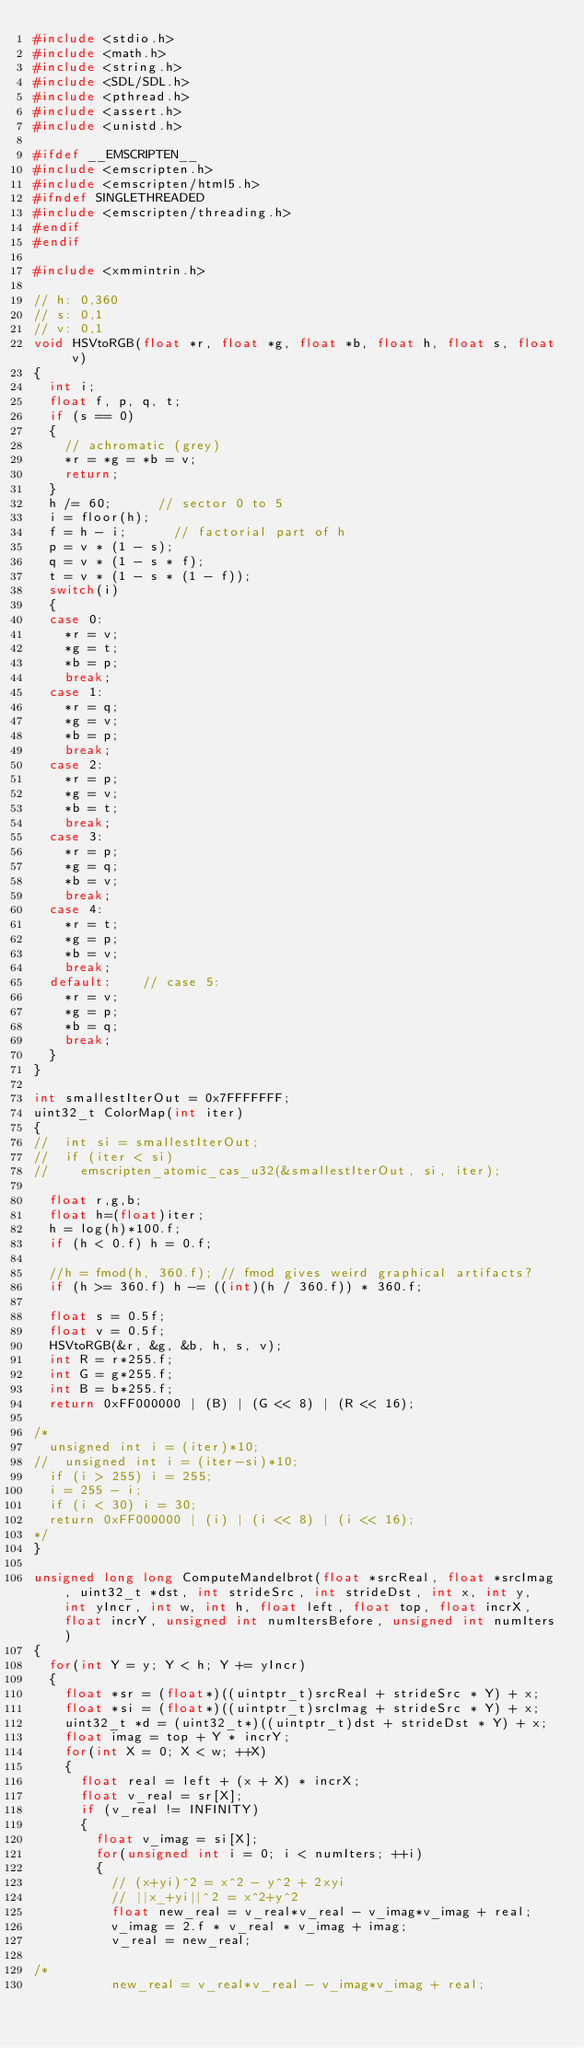<code> <loc_0><loc_0><loc_500><loc_500><_C++_>#include <stdio.h>
#include <math.h>
#include <string.h>
#include <SDL/SDL.h>
#include <pthread.h>
#include <assert.h>
#include <unistd.h>

#ifdef __EMSCRIPTEN__
#include <emscripten.h>
#include <emscripten/html5.h>
#ifndef SINGLETHREADED
#include <emscripten/threading.h>
#endif
#endif

#include <xmmintrin.h>

// h: 0,360
// s: 0,1
// v: 0,1
void HSVtoRGB(float *r, float *g, float *b, float h, float s, float v)
{
  int i;
  float f, p, q, t;
  if (s == 0)
  {
    // achromatic (grey)
    *r = *g = *b = v;
    return;
  }
  h /= 60;      // sector 0 to 5
  i = floor(h);
  f = h - i;      // factorial part of h
  p = v * (1 - s);
  q = v * (1 - s * f);
  t = v * (1 - s * (1 - f));
  switch(i)
  {
  case 0:
    *r = v;
    *g = t;
    *b = p;
    break;
  case 1:
    *r = q;
    *g = v;
    *b = p;
    break;
  case 2:
    *r = p;
    *g = v;
    *b = t;
    break;
  case 3:
    *r = p;
    *g = q;
    *b = v;
    break;
  case 4:
    *r = t;
    *g = p;
    *b = v;
    break;
  default:    // case 5:
    *r = v;
    *g = p;
    *b = q;
    break;
  }
}

int smallestIterOut = 0x7FFFFFFF;
uint32_t ColorMap(int iter)
{
//  int si = smallestIterOut;
//  if (iter < si)
//    emscripten_atomic_cas_u32(&smallestIterOut, si, iter);

  float r,g,b;
  float h=(float)iter;
  h = log(h)*100.f;
  if (h < 0.f) h = 0.f;

  //h = fmod(h, 360.f); // fmod gives weird graphical artifacts?
  if (h >= 360.f) h -= ((int)(h / 360.f)) * 360.f;

  float s = 0.5f;
  float v = 0.5f;
  HSVtoRGB(&r, &g, &b, h, s, v);
  int R = r*255.f;
  int G = g*255.f;
  int B = b*255.f;
  return 0xFF000000 | (B) | (G << 8) | (R << 16);

/*
  unsigned int i = (iter)*10;
//  unsigned int i = (iter-si)*10;
  if (i > 255) i = 255;
  i = 255 - i;
  if (i < 30) i = 30;
  return 0xFF000000 | (i) | (i << 8) | (i << 16);
*/
}

unsigned long long ComputeMandelbrot(float *srcReal, float *srcImag, uint32_t *dst, int strideSrc, int strideDst, int x, int y, int yIncr, int w, int h, float left, float top, float incrX, float incrY, unsigned int numItersBefore, unsigned int numIters)
{
  for(int Y = y; Y < h; Y += yIncr)
  {
    float *sr = (float*)((uintptr_t)srcReal + strideSrc * Y) + x;
    float *si = (float*)((uintptr_t)srcImag + strideSrc * Y) + x;
    uint32_t *d = (uint32_t*)((uintptr_t)dst + strideDst * Y) + x;
    float imag = top + Y * incrY;
    for(int X = 0; X < w; ++X)
    {
      float real = left + (x + X) * incrX;
      float v_real = sr[X];
      if (v_real != INFINITY)
      {
        float v_imag = si[X];
        for(unsigned int i = 0; i < numIters; ++i)
        {
          // (x+yi)^2 = x^2 - y^2 + 2xyi
          // ||x_+yi||^2 = x^2+y^2
          float new_real = v_real*v_real - v_imag*v_imag + real;
          v_imag = 2.f * v_real * v_imag + imag;
          v_real = new_real;

/*
          new_real = v_real*v_real - v_imag*v_imag + real;</code> 